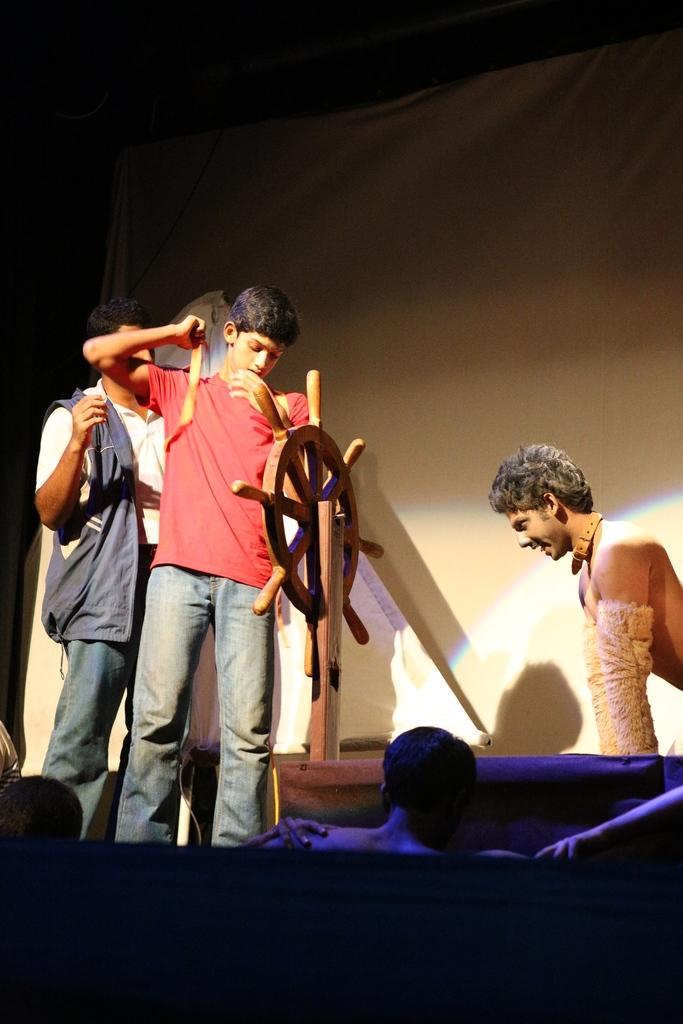In one or two sentences, can you explain what this image depicts? In the picture we can see two boys are standing, one boy is holding a small stick and he is in a red T-shirt and front of him we can see a boat steering to the wooden pole and a person sitting beside it and smiling and in the background we can see a wall, and in front of them we can see some people are sitting and watching the play. 